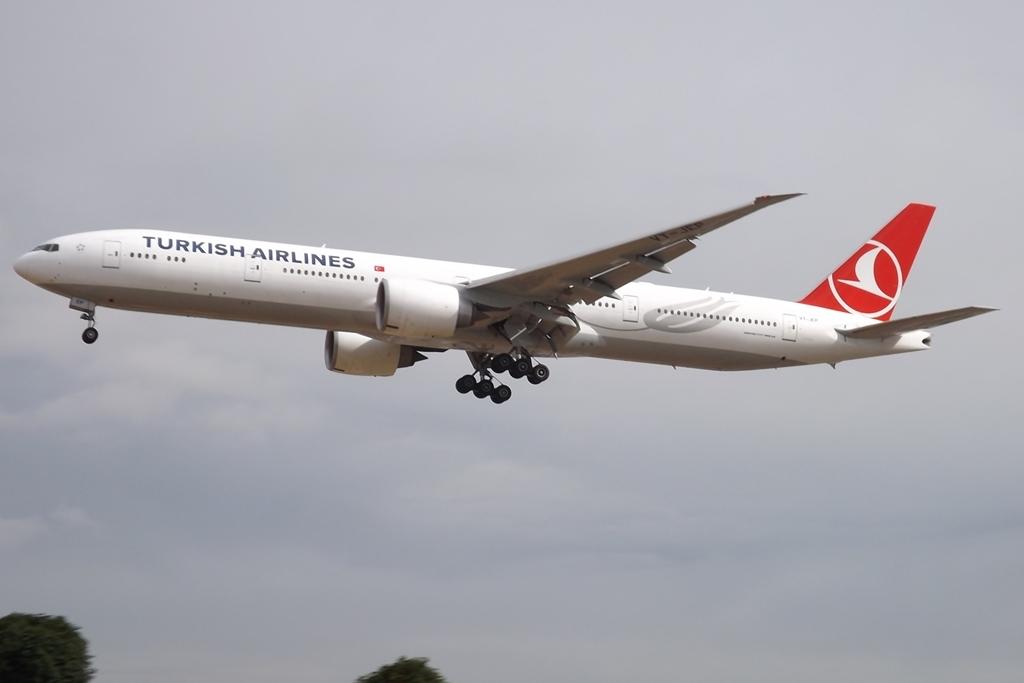Name of this airline company?
Offer a terse response. Turkish airlines. 